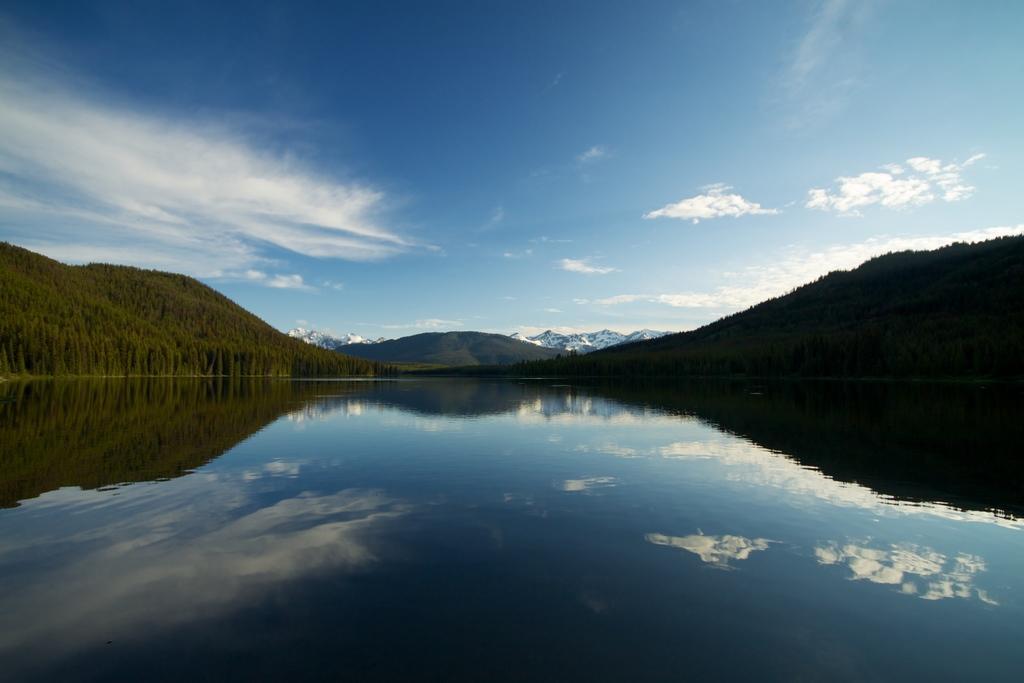Can you describe this image briefly? We can see water and trees. In the background we can see hills and sky with clouds. 